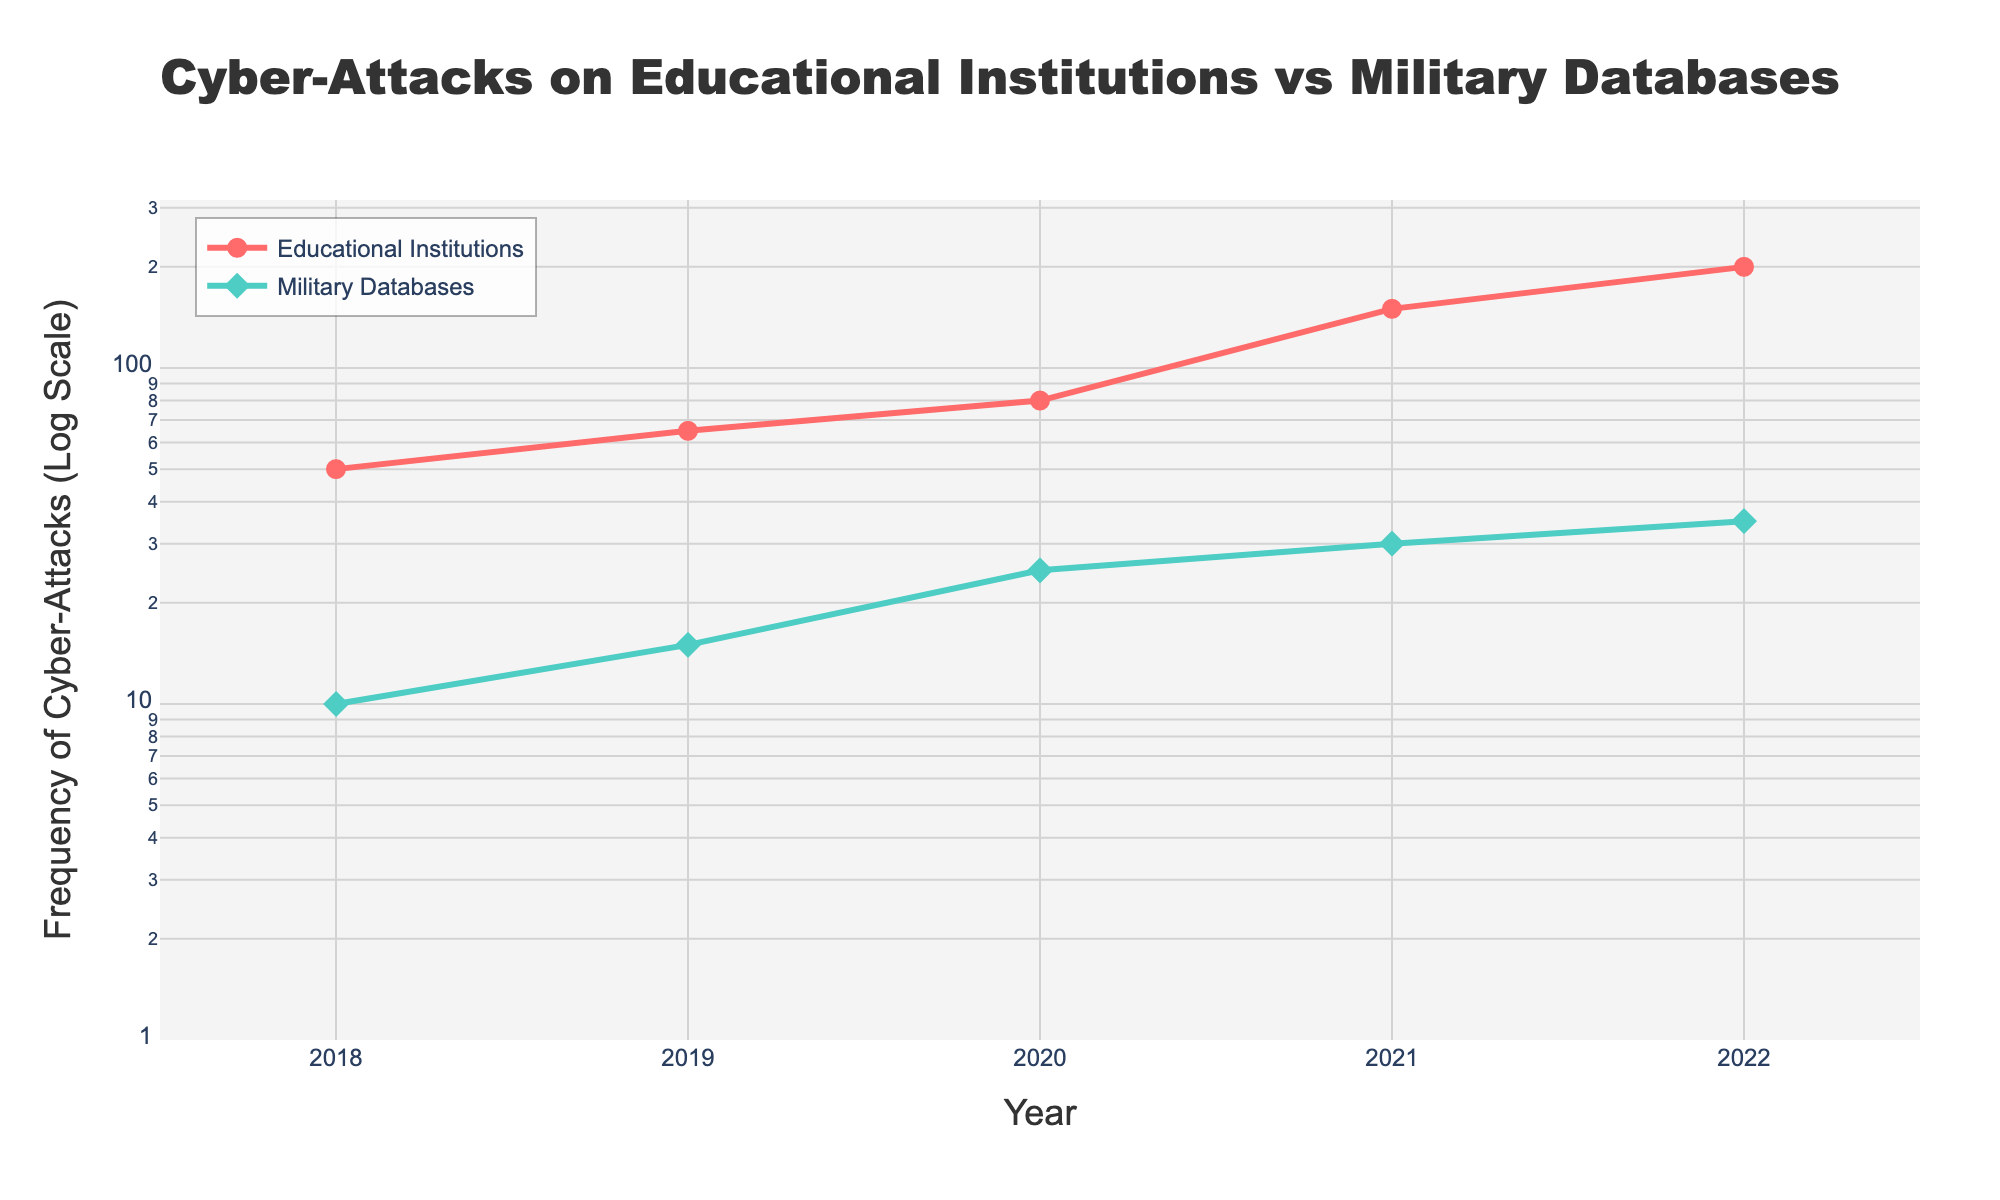What is the title of the figure? The title of the figure is located at the top of the plot. It helps to understand the context and main subject of the plot. The title reads "Cyber-Attacks on Educational Institutions vs Military Databases."
Answer: Cyber-Attacks on Educational Institutions vs Military Databases How many data points are there for each institution type? Count the markers for each line in the plot. For both Educational Institutions and Military Databases, there are data points for the years 2018, 2019, 2020, 2021, and 2022, which totals to 5 data points each.
Answer: 5 Which institution type experienced a higher number of cyber-attacks in 2021? Look for the data points for the year 2021 on both lines. The Educational Institutions line shows approximately 150 attacks, while the Military Databases line shows approximately 30 attacks.
Answer: Educational Institutions What is the difference in the number of cyber-attacks between Educational Institutions and Military Databases in 2020? For the year 2020, identify the values for both types: Educational Institutions had 80 attacks, and Military Databases had 25 attacks. Subtract 25 from 80.
Answer: 55 How did the frequency of cyber-attacks on Military Databases change from 2018 to 2022? Identify the data points for Military Databases for the years 2018 and 2022. In 2018, there were 10 attacks, and in 2022, there were 35 attacks. Calculate the difference between these two values.
Answer: Increased by 25 Which year saw the largest increase in cyber-attacks for Educational Institutions? Compare the differences in the number of attacks between consecutive years for Educational Institutions: 2018-2019 (15), 2019-2020 (15), 2020-2021 (70), 2021-2022 (50). The largest increase is from 2020 to 2021.
Answer: 2020 to 2021 Between which years did the number of cyber-attacks on Military Databases remain relatively stable? Compare the number of attacks across the years for Military Databases. Notice the values: 2018 (10), 2019 (15), 2020 (25), 2021 (30), 2022 (35). A relatively small increase of 5 attacks occurs between 2021 and 2022.
Answer: 2021 to 2022 On a log scale, which institution type shows a more consistent trend over the years? On the log scale, visually evaluate the slopes of both lines. The line for Military Databases seems to increase more steadily without large jumps, whereas the line for Educational Institutions has larger variations.
Answer: Military Databases 